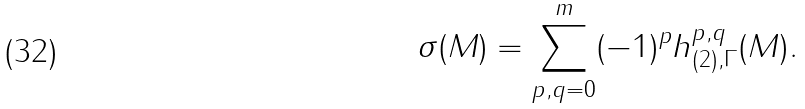Convert formula to latex. <formula><loc_0><loc_0><loc_500><loc_500>\sigma ( M ) = \sum _ { p , q = 0 } ^ { m } ( - 1 ) ^ { p } h _ { ( 2 ) , \Gamma } ^ { p , q } ( M ) .</formula> 